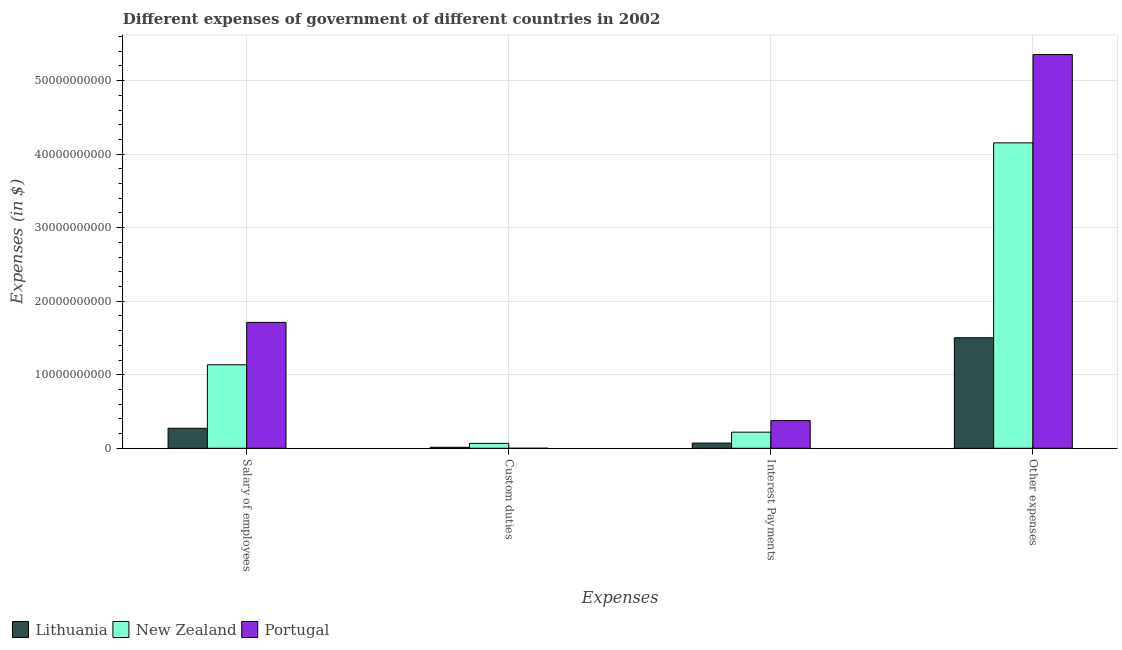How many different coloured bars are there?
Make the answer very short. 3. How many groups of bars are there?
Give a very brief answer. 4. Are the number of bars per tick equal to the number of legend labels?
Give a very brief answer. Yes. Are the number of bars on each tick of the X-axis equal?
Ensure brevity in your answer.  Yes. How many bars are there on the 1st tick from the left?
Your answer should be compact. 3. How many bars are there on the 2nd tick from the right?
Keep it short and to the point. 3. What is the label of the 4th group of bars from the left?
Provide a succinct answer. Other expenses. What is the amount spent on custom duties in Portugal?
Offer a very short reply. 5.10e+05. Across all countries, what is the maximum amount spent on salary of employees?
Your response must be concise. 1.71e+1. Across all countries, what is the minimum amount spent on other expenses?
Provide a short and direct response. 1.50e+1. In which country was the amount spent on other expenses minimum?
Make the answer very short. Lithuania. What is the total amount spent on salary of employees in the graph?
Your answer should be compact. 3.12e+1. What is the difference between the amount spent on interest payments in New Zealand and that in Portugal?
Provide a short and direct response. -1.57e+09. What is the difference between the amount spent on other expenses in New Zealand and the amount spent on interest payments in Lithuania?
Keep it short and to the point. 4.08e+1. What is the average amount spent on interest payments per country?
Make the answer very short. 2.22e+09. What is the difference between the amount spent on interest payments and amount spent on salary of employees in Lithuania?
Your answer should be very brief. -2.01e+09. What is the ratio of the amount spent on other expenses in New Zealand to that in Lithuania?
Offer a very short reply. 2.76. Is the amount spent on interest payments in Portugal less than that in Lithuania?
Keep it short and to the point. No. What is the difference between the highest and the second highest amount spent on other expenses?
Your answer should be compact. 1.20e+1. What is the difference between the highest and the lowest amount spent on custom duties?
Keep it short and to the point. 6.65e+08. In how many countries, is the amount spent on salary of employees greater than the average amount spent on salary of employees taken over all countries?
Your response must be concise. 2. What does the 3rd bar from the left in Interest Payments represents?
Offer a terse response. Portugal. What does the 1st bar from the right in Interest Payments represents?
Provide a succinct answer. Portugal. How many bars are there?
Keep it short and to the point. 12. How many countries are there in the graph?
Your answer should be very brief. 3. Does the graph contain any zero values?
Give a very brief answer. No. Does the graph contain grids?
Make the answer very short. Yes. Where does the legend appear in the graph?
Provide a short and direct response. Bottom left. What is the title of the graph?
Give a very brief answer. Different expenses of government of different countries in 2002. Does "Korea (Democratic)" appear as one of the legend labels in the graph?
Your answer should be compact. No. What is the label or title of the X-axis?
Provide a short and direct response. Expenses. What is the label or title of the Y-axis?
Give a very brief answer. Expenses (in $). What is the Expenses (in $) in Lithuania in Salary of employees?
Offer a terse response. 2.72e+09. What is the Expenses (in $) of New Zealand in Salary of employees?
Make the answer very short. 1.14e+1. What is the Expenses (in $) in Portugal in Salary of employees?
Provide a succinct answer. 1.71e+1. What is the Expenses (in $) in Lithuania in Custom duties?
Make the answer very short. 1.32e+08. What is the Expenses (in $) of New Zealand in Custom duties?
Give a very brief answer. 6.66e+08. What is the Expenses (in $) of Portugal in Custom duties?
Offer a terse response. 5.10e+05. What is the Expenses (in $) in Lithuania in Interest Payments?
Provide a short and direct response. 7.06e+08. What is the Expenses (in $) of New Zealand in Interest Payments?
Offer a very short reply. 2.19e+09. What is the Expenses (in $) in Portugal in Interest Payments?
Ensure brevity in your answer.  3.76e+09. What is the Expenses (in $) in Lithuania in Other expenses?
Offer a very short reply. 1.50e+1. What is the Expenses (in $) of New Zealand in Other expenses?
Your answer should be very brief. 4.15e+1. What is the Expenses (in $) of Portugal in Other expenses?
Make the answer very short. 5.35e+1. Across all Expenses, what is the maximum Expenses (in $) of Lithuania?
Provide a short and direct response. 1.50e+1. Across all Expenses, what is the maximum Expenses (in $) of New Zealand?
Offer a terse response. 4.15e+1. Across all Expenses, what is the maximum Expenses (in $) of Portugal?
Your response must be concise. 5.35e+1. Across all Expenses, what is the minimum Expenses (in $) of Lithuania?
Give a very brief answer. 1.32e+08. Across all Expenses, what is the minimum Expenses (in $) of New Zealand?
Your answer should be very brief. 6.66e+08. Across all Expenses, what is the minimum Expenses (in $) of Portugal?
Offer a terse response. 5.10e+05. What is the total Expenses (in $) in Lithuania in the graph?
Keep it short and to the point. 1.86e+1. What is the total Expenses (in $) in New Zealand in the graph?
Make the answer very short. 5.57e+1. What is the total Expenses (in $) of Portugal in the graph?
Offer a very short reply. 7.44e+1. What is the difference between the Expenses (in $) in Lithuania in Salary of employees and that in Custom duties?
Make the answer very short. 2.59e+09. What is the difference between the Expenses (in $) in New Zealand in Salary of employees and that in Custom duties?
Offer a very short reply. 1.07e+1. What is the difference between the Expenses (in $) of Portugal in Salary of employees and that in Custom duties?
Provide a short and direct response. 1.71e+1. What is the difference between the Expenses (in $) in Lithuania in Salary of employees and that in Interest Payments?
Your answer should be very brief. 2.01e+09. What is the difference between the Expenses (in $) of New Zealand in Salary of employees and that in Interest Payments?
Your response must be concise. 9.16e+09. What is the difference between the Expenses (in $) in Portugal in Salary of employees and that in Interest Payments?
Offer a terse response. 1.34e+1. What is the difference between the Expenses (in $) in Lithuania in Salary of employees and that in Other expenses?
Your answer should be very brief. -1.23e+1. What is the difference between the Expenses (in $) of New Zealand in Salary of employees and that in Other expenses?
Offer a very short reply. -3.02e+1. What is the difference between the Expenses (in $) in Portugal in Salary of employees and that in Other expenses?
Your response must be concise. -3.64e+1. What is the difference between the Expenses (in $) of Lithuania in Custom duties and that in Interest Payments?
Keep it short and to the point. -5.74e+08. What is the difference between the Expenses (in $) in New Zealand in Custom duties and that in Interest Payments?
Give a very brief answer. -1.53e+09. What is the difference between the Expenses (in $) of Portugal in Custom duties and that in Interest Payments?
Your answer should be very brief. -3.76e+09. What is the difference between the Expenses (in $) in Lithuania in Custom duties and that in Other expenses?
Your response must be concise. -1.49e+1. What is the difference between the Expenses (in $) in New Zealand in Custom duties and that in Other expenses?
Provide a succinct answer. -4.09e+1. What is the difference between the Expenses (in $) in Portugal in Custom duties and that in Other expenses?
Ensure brevity in your answer.  -5.35e+1. What is the difference between the Expenses (in $) of Lithuania in Interest Payments and that in Other expenses?
Offer a very short reply. -1.43e+1. What is the difference between the Expenses (in $) of New Zealand in Interest Payments and that in Other expenses?
Keep it short and to the point. -3.93e+1. What is the difference between the Expenses (in $) of Portugal in Interest Payments and that in Other expenses?
Your answer should be very brief. -4.98e+1. What is the difference between the Expenses (in $) in Lithuania in Salary of employees and the Expenses (in $) in New Zealand in Custom duties?
Offer a very short reply. 2.05e+09. What is the difference between the Expenses (in $) of Lithuania in Salary of employees and the Expenses (in $) of Portugal in Custom duties?
Your response must be concise. 2.72e+09. What is the difference between the Expenses (in $) of New Zealand in Salary of employees and the Expenses (in $) of Portugal in Custom duties?
Offer a very short reply. 1.14e+1. What is the difference between the Expenses (in $) in Lithuania in Salary of employees and the Expenses (in $) in New Zealand in Interest Payments?
Your answer should be compact. 5.25e+08. What is the difference between the Expenses (in $) in Lithuania in Salary of employees and the Expenses (in $) in Portugal in Interest Payments?
Your response must be concise. -1.05e+09. What is the difference between the Expenses (in $) in New Zealand in Salary of employees and the Expenses (in $) in Portugal in Interest Payments?
Your response must be concise. 7.59e+09. What is the difference between the Expenses (in $) of Lithuania in Salary of employees and the Expenses (in $) of New Zealand in Other expenses?
Your response must be concise. -3.88e+1. What is the difference between the Expenses (in $) in Lithuania in Salary of employees and the Expenses (in $) in Portugal in Other expenses?
Give a very brief answer. -5.08e+1. What is the difference between the Expenses (in $) of New Zealand in Salary of employees and the Expenses (in $) of Portugal in Other expenses?
Your answer should be very brief. -4.22e+1. What is the difference between the Expenses (in $) of Lithuania in Custom duties and the Expenses (in $) of New Zealand in Interest Payments?
Provide a succinct answer. -2.06e+09. What is the difference between the Expenses (in $) in Lithuania in Custom duties and the Expenses (in $) in Portugal in Interest Payments?
Give a very brief answer. -3.63e+09. What is the difference between the Expenses (in $) of New Zealand in Custom duties and the Expenses (in $) of Portugal in Interest Payments?
Ensure brevity in your answer.  -3.10e+09. What is the difference between the Expenses (in $) in Lithuania in Custom duties and the Expenses (in $) in New Zealand in Other expenses?
Keep it short and to the point. -4.14e+1. What is the difference between the Expenses (in $) of Lithuania in Custom duties and the Expenses (in $) of Portugal in Other expenses?
Ensure brevity in your answer.  -5.34e+1. What is the difference between the Expenses (in $) in New Zealand in Custom duties and the Expenses (in $) in Portugal in Other expenses?
Offer a very short reply. -5.29e+1. What is the difference between the Expenses (in $) in Lithuania in Interest Payments and the Expenses (in $) in New Zealand in Other expenses?
Give a very brief answer. -4.08e+1. What is the difference between the Expenses (in $) of Lithuania in Interest Payments and the Expenses (in $) of Portugal in Other expenses?
Provide a short and direct response. -5.28e+1. What is the difference between the Expenses (in $) in New Zealand in Interest Payments and the Expenses (in $) in Portugal in Other expenses?
Make the answer very short. -5.13e+1. What is the average Expenses (in $) in Lithuania per Expenses?
Provide a short and direct response. 4.65e+09. What is the average Expenses (in $) of New Zealand per Expenses?
Provide a succinct answer. 1.39e+1. What is the average Expenses (in $) of Portugal per Expenses?
Your response must be concise. 1.86e+1. What is the difference between the Expenses (in $) of Lithuania and Expenses (in $) of New Zealand in Salary of employees?
Your answer should be very brief. -8.64e+09. What is the difference between the Expenses (in $) in Lithuania and Expenses (in $) in Portugal in Salary of employees?
Make the answer very short. -1.44e+1. What is the difference between the Expenses (in $) of New Zealand and Expenses (in $) of Portugal in Salary of employees?
Provide a short and direct response. -5.76e+09. What is the difference between the Expenses (in $) of Lithuania and Expenses (in $) of New Zealand in Custom duties?
Offer a terse response. -5.33e+08. What is the difference between the Expenses (in $) in Lithuania and Expenses (in $) in Portugal in Custom duties?
Provide a succinct answer. 1.32e+08. What is the difference between the Expenses (in $) in New Zealand and Expenses (in $) in Portugal in Custom duties?
Provide a short and direct response. 6.65e+08. What is the difference between the Expenses (in $) of Lithuania and Expenses (in $) of New Zealand in Interest Payments?
Your answer should be very brief. -1.49e+09. What is the difference between the Expenses (in $) in Lithuania and Expenses (in $) in Portugal in Interest Payments?
Offer a very short reply. -3.06e+09. What is the difference between the Expenses (in $) of New Zealand and Expenses (in $) of Portugal in Interest Payments?
Provide a short and direct response. -1.57e+09. What is the difference between the Expenses (in $) of Lithuania and Expenses (in $) of New Zealand in Other expenses?
Make the answer very short. -2.65e+1. What is the difference between the Expenses (in $) in Lithuania and Expenses (in $) in Portugal in Other expenses?
Provide a short and direct response. -3.85e+1. What is the difference between the Expenses (in $) in New Zealand and Expenses (in $) in Portugal in Other expenses?
Provide a short and direct response. -1.20e+1. What is the ratio of the Expenses (in $) of Lithuania in Salary of employees to that in Custom duties?
Provide a short and direct response. 20.51. What is the ratio of the Expenses (in $) in New Zealand in Salary of employees to that in Custom duties?
Provide a succinct answer. 17.06. What is the ratio of the Expenses (in $) of Portugal in Salary of employees to that in Custom duties?
Your answer should be compact. 3.36e+04. What is the ratio of the Expenses (in $) in Lithuania in Salary of employees to that in Interest Payments?
Offer a terse response. 3.85. What is the ratio of the Expenses (in $) in New Zealand in Salary of employees to that in Interest Payments?
Provide a short and direct response. 5.18. What is the ratio of the Expenses (in $) in Portugal in Salary of employees to that in Interest Payments?
Your response must be concise. 4.55. What is the ratio of the Expenses (in $) in Lithuania in Salary of employees to that in Other expenses?
Your answer should be compact. 0.18. What is the ratio of the Expenses (in $) in New Zealand in Salary of employees to that in Other expenses?
Offer a very short reply. 0.27. What is the ratio of the Expenses (in $) in Portugal in Salary of employees to that in Other expenses?
Offer a very short reply. 0.32. What is the ratio of the Expenses (in $) in Lithuania in Custom duties to that in Interest Payments?
Make the answer very short. 0.19. What is the ratio of the Expenses (in $) in New Zealand in Custom duties to that in Interest Payments?
Your response must be concise. 0.3. What is the ratio of the Expenses (in $) in Lithuania in Custom duties to that in Other expenses?
Give a very brief answer. 0.01. What is the ratio of the Expenses (in $) of New Zealand in Custom duties to that in Other expenses?
Provide a succinct answer. 0.02. What is the ratio of the Expenses (in $) of Lithuania in Interest Payments to that in Other expenses?
Your response must be concise. 0.05. What is the ratio of the Expenses (in $) in New Zealand in Interest Payments to that in Other expenses?
Provide a short and direct response. 0.05. What is the ratio of the Expenses (in $) of Portugal in Interest Payments to that in Other expenses?
Ensure brevity in your answer.  0.07. What is the difference between the highest and the second highest Expenses (in $) in Lithuania?
Your response must be concise. 1.23e+1. What is the difference between the highest and the second highest Expenses (in $) in New Zealand?
Make the answer very short. 3.02e+1. What is the difference between the highest and the second highest Expenses (in $) of Portugal?
Make the answer very short. 3.64e+1. What is the difference between the highest and the lowest Expenses (in $) in Lithuania?
Your answer should be compact. 1.49e+1. What is the difference between the highest and the lowest Expenses (in $) in New Zealand?
Give a very brief answer. 4.09e+1. What is the difference between the highest and the lowest Expenses (in $) of Portugal?
Offer a terse response. 5.35e+1. 